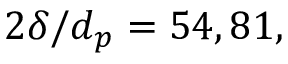<formula> <loc_0><loc_0><loc_500><loc_500>2 \delta / d _ { p } = 5 4 , 8 1 ,</formula> 